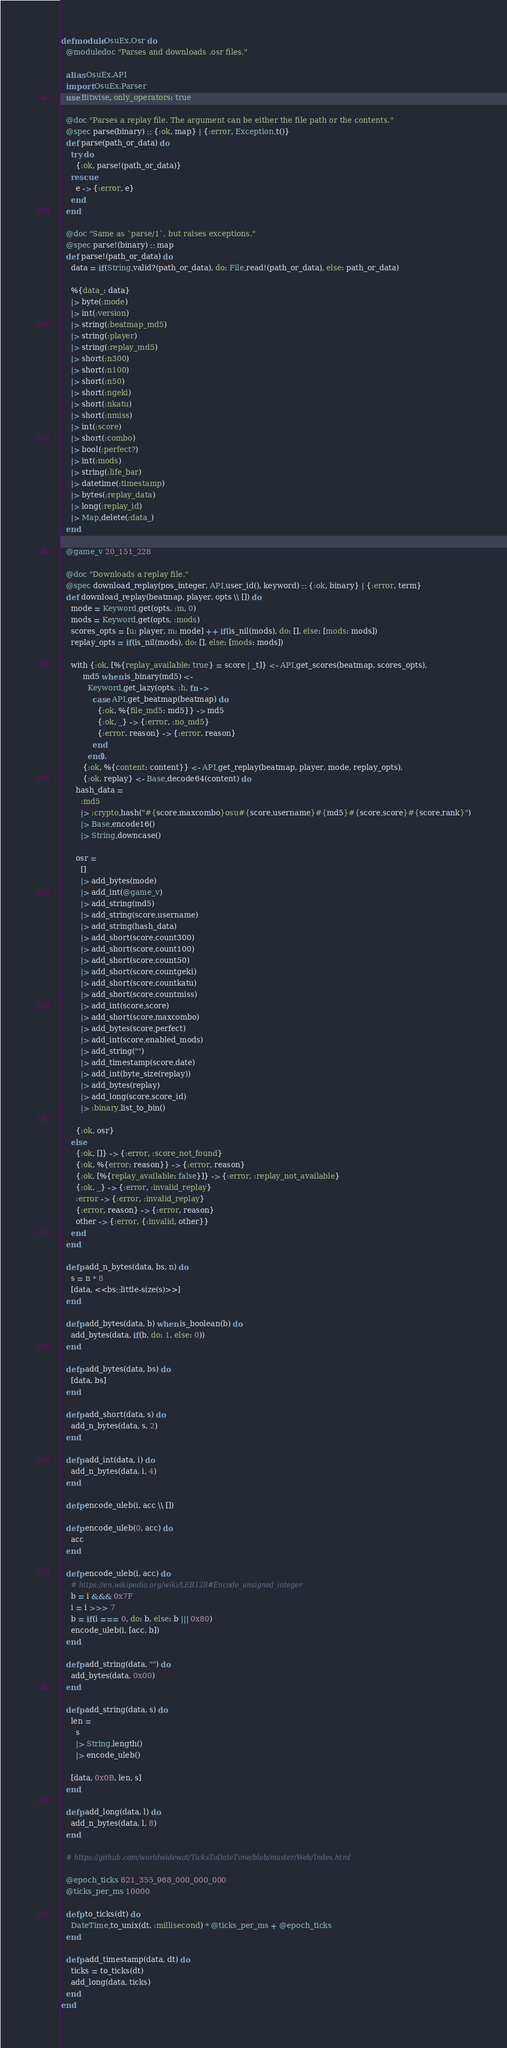<code> <loc_0><loc_0><loc_500><loc_500><_Elixir_>defmodule OsuEx.Osr do
  @moduledoc "Parses and downloads .osr files."

  alias OsuEx.API
  import OsuEx.Parser
  use Bitwise, only_operators: true

  @doc "Parses a replay file. The argument can be either the file path or the contents."
  @spec parse(binary) :: {:ok, map} | {:error, Exception.t()}
  def parse(path_or_data) do
    try do
      {:ok, parse!(path_or_data)}
    rescue
      e -> {:error, e}
    end
  end

  @doc "Same as `parse/1`, but raises exceptions."
  @spec parse!(binary) :: map
  def parse!(path_or_data) do
    data = if(String.valid?(path_or_data), do: File.read!(path_or_data), else: path_or_data)

    %{data_: data}
    |> byte(:mode)
    |> int(:version)
    |> string(:beatmap_md5)
    |> string(:player)
    |> string(:replay_md5)
    |> short(:n300)
    |> short(:n100)
    |> short(:n50)
    |> short(:ngeki)
    |> short(:nkatu)
    |> short(:nmiss)
    |> int(:score)
    |> short(:combo)
    |> bool(:perfect?)
    |> int(:mods)
    |> string(:life_bar)
    |> datetime(:timestamp)
    |> bytes(:replay_data)
    |> long(:replay_id)
    |> Map.delete(:data_)
  end

  @game_v 20_151_228

  @doc "Downloads a replay file."
  @spec download_replay(pos_integer, API.user_id(), keyword) :: {:ok, binary} | {:error, term}
  def download_replay(beatmap, player, opts \\ []) do
    mode = Keyword.get(opts, :m, 0)
    mods = Keyword.get(opts, :mods)
    scores_opts = [u: player, m: mode] ++ if(is_nil(mods), do: [], else: [mods: mods])
    replay_opts = if(is_nil(mods), do: [], else: [mods: mods])

    with {:ok, [%{replay_available: true} = score | _t]} <- API.get_scores(beatmap, scores_opts),
         md5 when is_binary(md5) <-
           Keyword.get_lazy(opts, :h, fn ->
             case API.get_beatmap(beatmap) do
               {:ok, %{file_md5: md5}} -> md5
               {:ok, _} -> {:error, :no_md5}
               {:error, reason} -> {:error, reason}
             end
           end),
         {:ok, %{content: content}} <- API.get_replay(beatmap, player, mode, replay_opts),
         {:ok, replay} <- Base.decode64(content) do
      hash_data =
        :md5
        |> :crypto.hash("#{score.maxcombo}osu#{score.username}#{md5}#{score.score}#{score.rank}")
        |> Base.encode16()
        |> String.downcase()

      osr =
        []
        |> add_bytes(mode)
        |> add_int(@game_v)
        |> add_string(md5)
        |> add_string(score.username)
        |> add_string(hash_data)
        |> add_short(score.count300)
        |> add_short(score.count100)
        |> add_short(score.count50)
        |> add_short(score.countgeki)
        |> add_short(score.countkatu)
        |> add_short(score.countmiss)
        |> add_int(score.score)
        |> add_short(score.maxcombo)
        |> add_bytes(score.perfect)
        |> add_int(score.enabled_mods)
        |> add_string("")
        |> add_timestamp(score.date)
        |> add_int(byte_size(replay))
        |> add_bytes(replay)
        |> add_long(score.score_id)
        |> :binary.list_to_bin()

      {:ok, osr}
    else
      {:ok, []} -> {:error, :score_not_found}
      {:ok, %{error: reason}} -> {:error, reason}
      {:ok, [%{replay_available: false}]} -> {:error, :replay_not_available}
      {:ok, _} -> {:error, :invalid_replay}
      :error -> {:error, :invalid_replay}
      {:error, reason} -> {:error, reason}
      other -> {:error, {:invalid, other}}
    end
  end

  defp add_n_bytes(data, bs, n) do
    s = n * 8
    [data, <<bs::little-size(s)>>]
  end

  defp add_bytes(data, b) when is_boolean(b) do
    add_bytes(data, if(b, do: 1, else: 0))
  end

  defp add_bytes(data, bs) do
    [data, bs]
  end

  defp add_short(data, s) do
    add_n_bytes(data, s, 2)
  end

  defp add_int(data, i) do
    add_n_bytes(data, i, 4)
  end

  defp encode_uleb(i, acc \\ [])

  defp encode_uleb(0, acc) do
    acc
  end

  defp encode_uleb(i, acc) do
    # https://en.wikipedia.org/wiki/LEB128#Encode_unsigned_integer
    b = i &&& 0x7F
    i = i >>> 7
    b = if(i === 0, do: b, else: b ||| 0x80)
    encode_uleb(i, [acc, b])
  end

  defp add_string(data, "") do
    add_bytes(data, 0x00)
  end

  defp add_string(data, s) do
    len =
      s
      |> String.length()
      |> encode_uleb()

    [data, 0x0B, len, s]
  end

  defp add_long(data, l) do
    add_n_bytes(data, l, 8)
  end

  # https://github.com/worldwidewat/TicksToDateTime/blob/master/Web/Index.html

  @epoch_ticks 621_355_968_000_000_000
  @ticks_per_ms 10000

  defp to_ticks(dt) do
    DateTime.to_unix(dt, :millisecond) * @ticks_per_ms + @epoch_ticks
  end

  defp add_timestamp(data, dt) do
    ticks = to_ticks(dt)
    add_long(data, ticks)
  end
end
</code> 